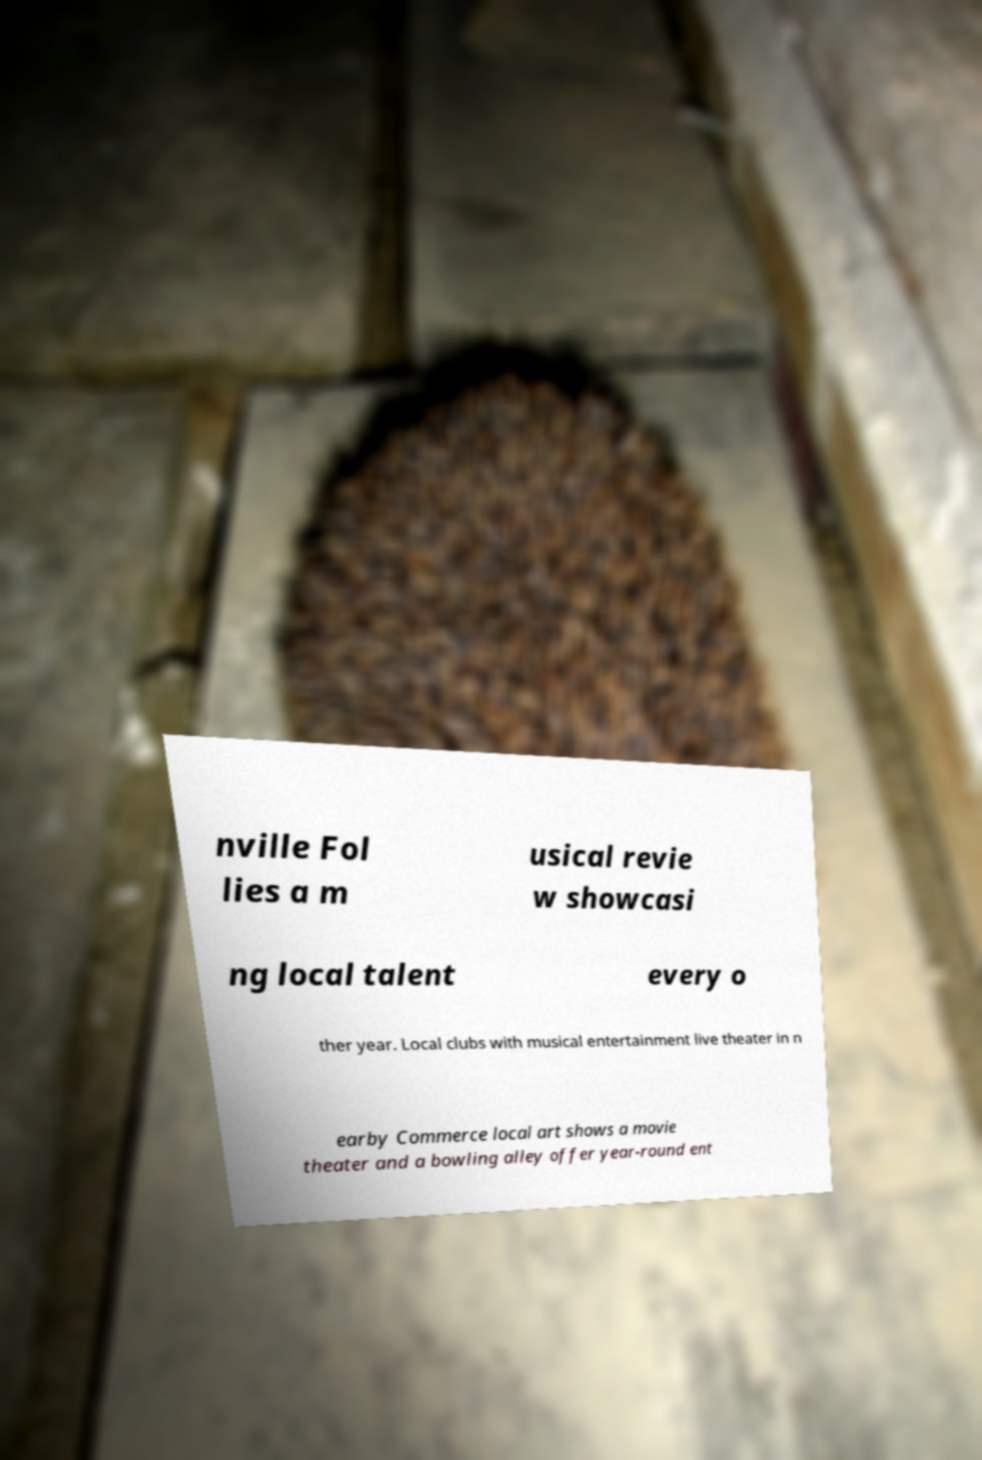I need the written content from this picture converted into text. Can you do that? nville Fol lies a m usical revie w showcasi ng local talent every o ther year. Local clubs with musical entertainment live theater in n earby Commerce local art shows a movie theater and a bowling alley offer year-round ent 